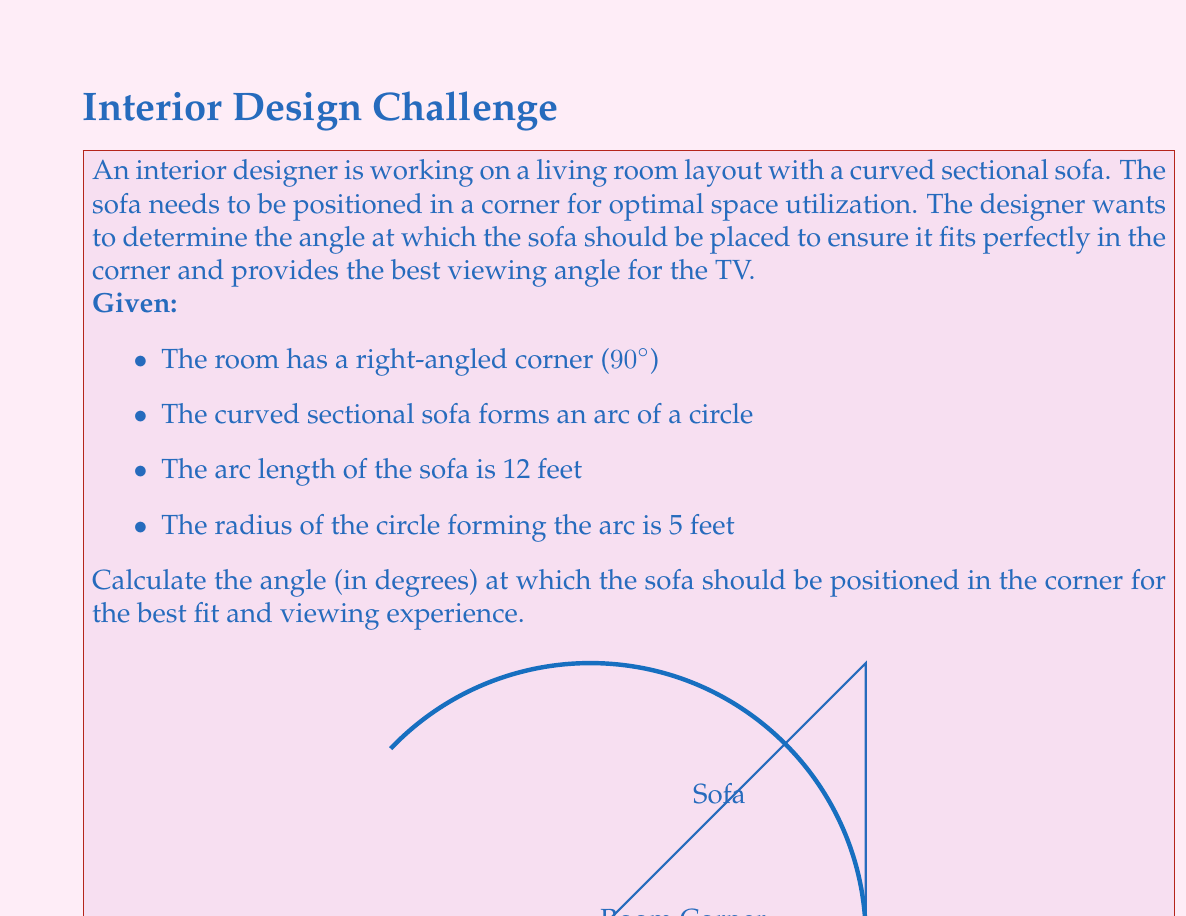Can you solve this math problem? To solve this problem, we'll follow these steps:

1) First, we need to find the central angle of the arc formed by the sofa. We can use the arc length formula:

   $$ s = r\theta $$

   Where $s$ is the arc length, $r$ is the radius, and $\theta$ is the central angle in radians.

2) We know $s = 12$ feet and $r = 5$ feet. Let's substitute these values:

   $$ 12 = 5\theta $$

3) Solve for $\theta$:

   $$ \theta = \frac{12}{5} = 2.4 \text{ radians} $$

4) Convert radians to degrees:

   $$ \theta_{degrees} = 2.4 \times \frac{180}{\pi} \approx 137.5° $$

5) This angle represents the full arc of the sofa. However, we want to position the sofa in a 90° corner. To find the angle at which to position the sofa, we need to subtract this from 180°:

   $$ \text{Positioning angle} = 180° - 137.5° = 42.5° $$

Therefore, the sofa should be positioned at a 42.5° angle from each wall in the corner.
Answer: 42.5° 